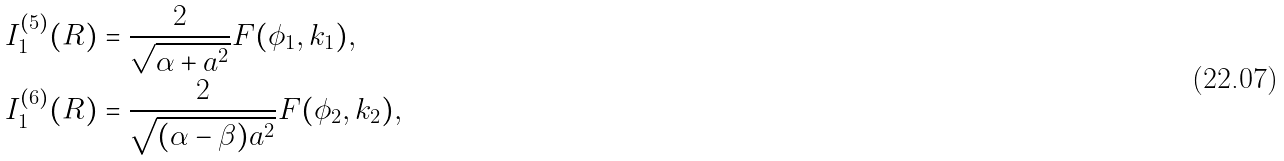Convert formula to latex. <formula><loc_0><loc_0><loc_500><loc_500>I _ { 1 } ^ { ( 5 ) } ( R ) & = \frac { 2 } { \sqrt { \alpha + a ^ { 2 } } } F ( \phi _ { 1 } , k _ { 1 } ) , \\ I _ { 1 } ^ { ( 6 ) } ( R ) & = \frac { 2 } { \sqrt { ( \alpha - \beta ) a ^ { 2 } } } F ( \phi _ { 2 } , k _ { 2 } ) ,</formula> 